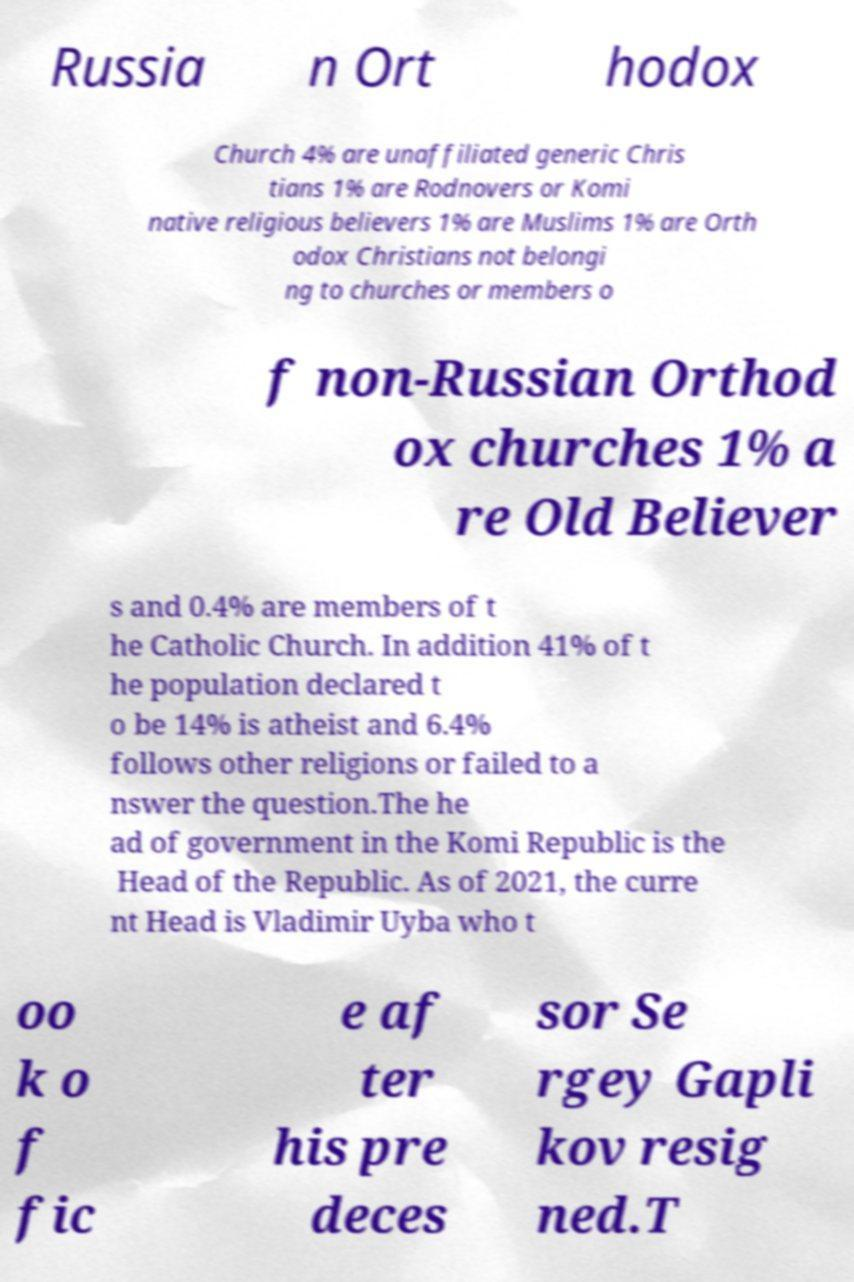What messages or text are displayed in this image? I need them in a readable, typed format. Russia n Ort hodox Church 4% are unaffiliated generic Chris tians 1% are Rodnovers or Komi native religious believers 1% are Muslims 1% are Orth odox Christians not belongi ng to churches or members o f non-Russian Orthod ox churches 1% a re Old Believer s and 0.4% are members of t he Catholic Church. In addition 41% of t he population declared t o be 14% is atheist and 6.4% follows other religions or failed to a nswer the question.The he ad of government in the Komi Republic is the Head of the Republic. As of 2021, the curre nt Head is Vladimir Uyba who t oo k o f fic e af ter his pre deces sor Se rgey Gapli kov resig ned.T 